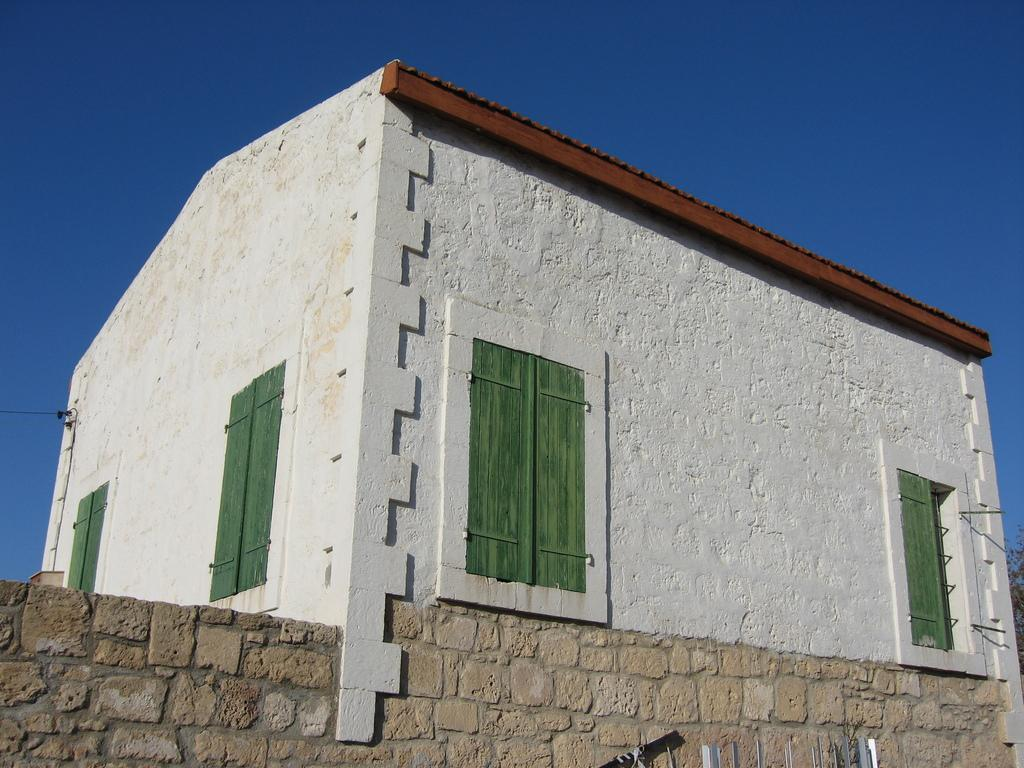What type of structure is present in the image? There is a building in the image. What can be seen in the background of the image? The sky is visible in the background of the image. What type of neck accessory is visible on the building in the image? There is no neck accessory present on the building in the image. 